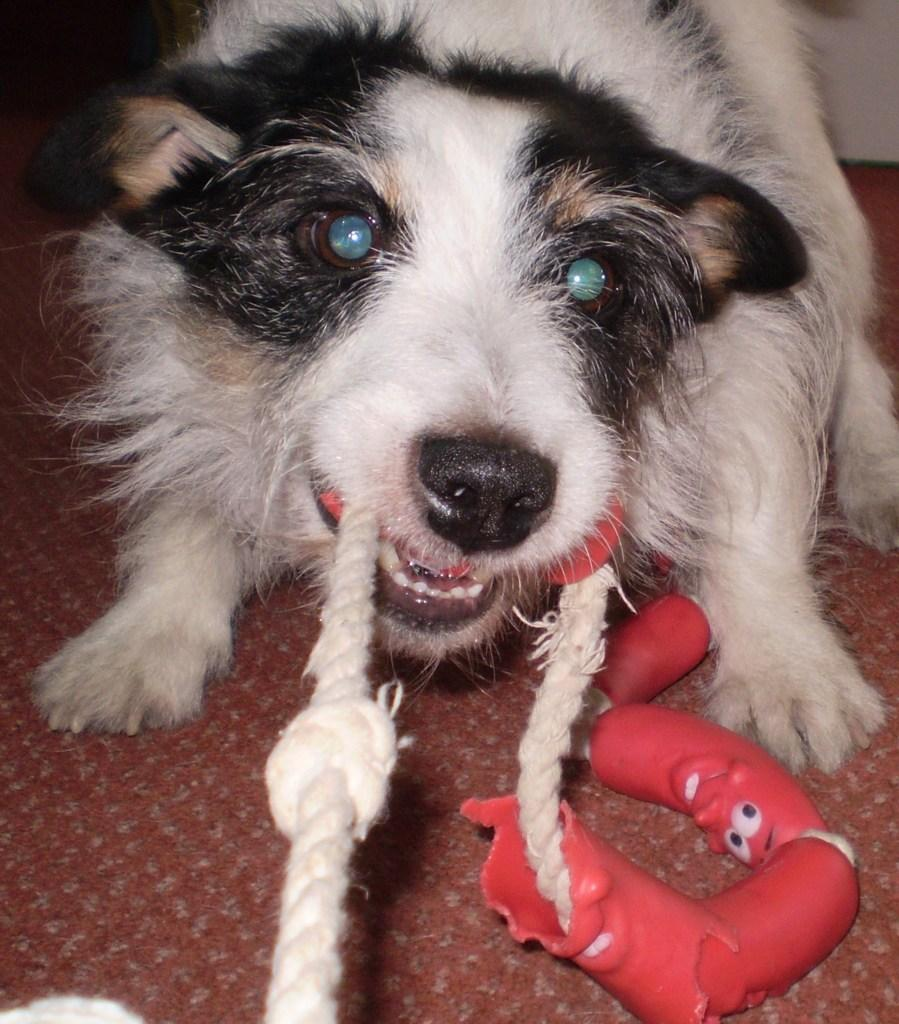What type of animal is in the picture? There is a fluffy dog in the picture. What is the dog doing in the picture? The dog is playing on the ground. What object is the dog holding in its mouth? The dog is holding a rope in its mouth. How much payment does the family owe for the dog's toys in the picture? There is no mention of a family or payment in the image, and the dog is holding a rope, not a toy. 